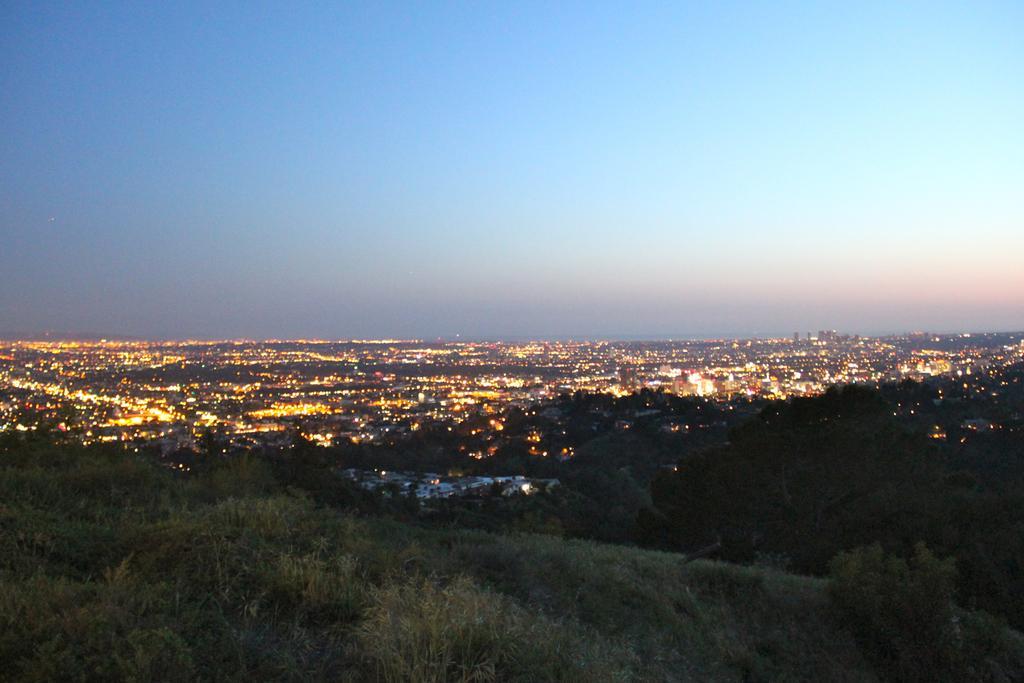How would you summarize this image in a sentence or two? In this picture I can see trees, lights, and in the background there is sky. 